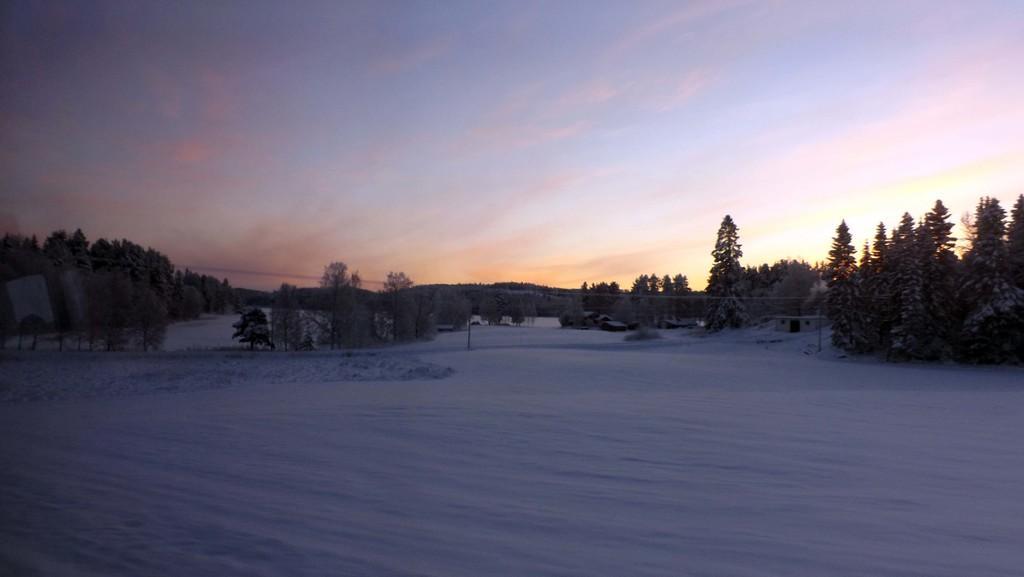Can you describe this image briefly? In this image we can see snow on the ground, poles, houses, trees, objects and clouds in the sky. 